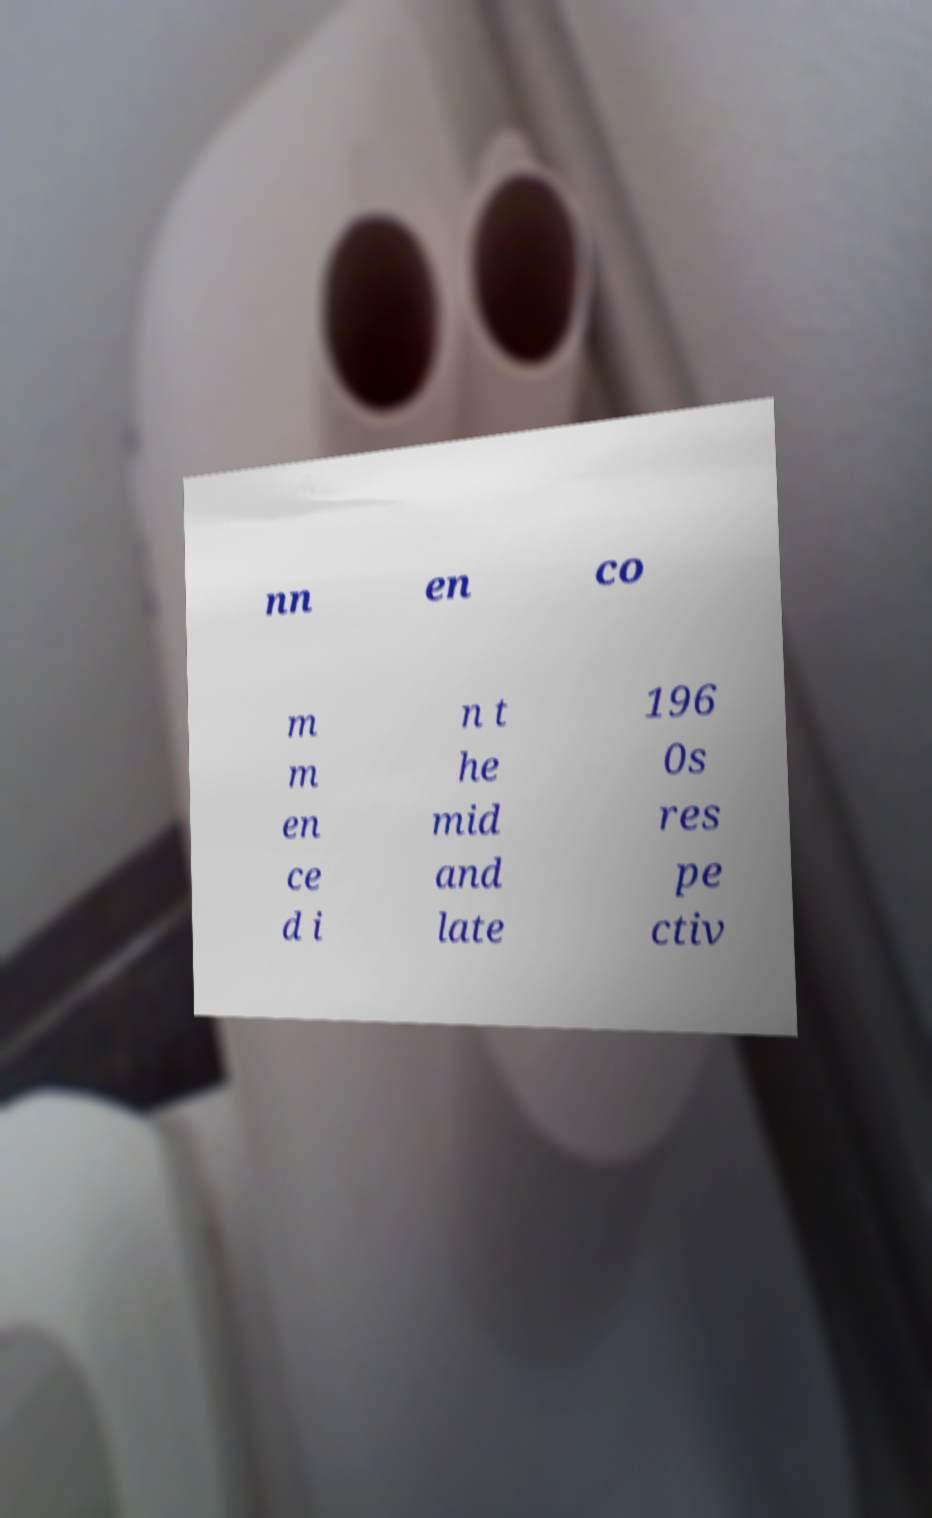Please identify and transcribe the text found in this image. nn en co m m en ce d i n t he mid and late 196 0s res pe ctiv 